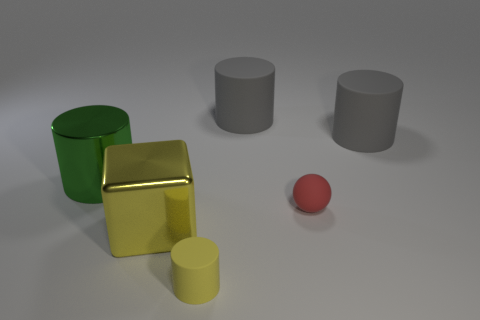Add 1 small yellow matte objects. How many objects exist? 7 Subtract all spheres. How many objects are left? 5 Subtract 1 red balls. How many objects are left? 5 Subtract all cubes. Subtract all tiny red balls. How many objects are left? 4 Add 5 red balls. How many red balls are left? 6 Add 5 big things. How many big things exist? 9 